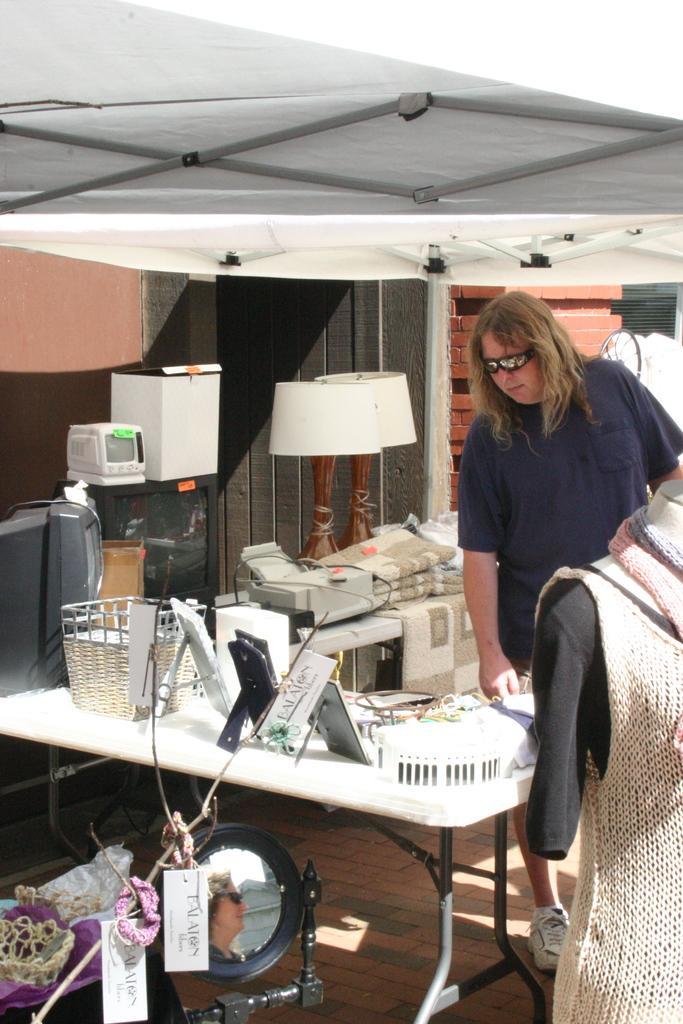Can you describe this image briefly? In this picture I can see a mannequin on the right side and I see a table in front on which there are many things and I see a TV, 2 lamps, a printer, another TV and a person near to them. On the bottom of this picture I see a mirror and few more things. On the top of this picture I see the shed. 